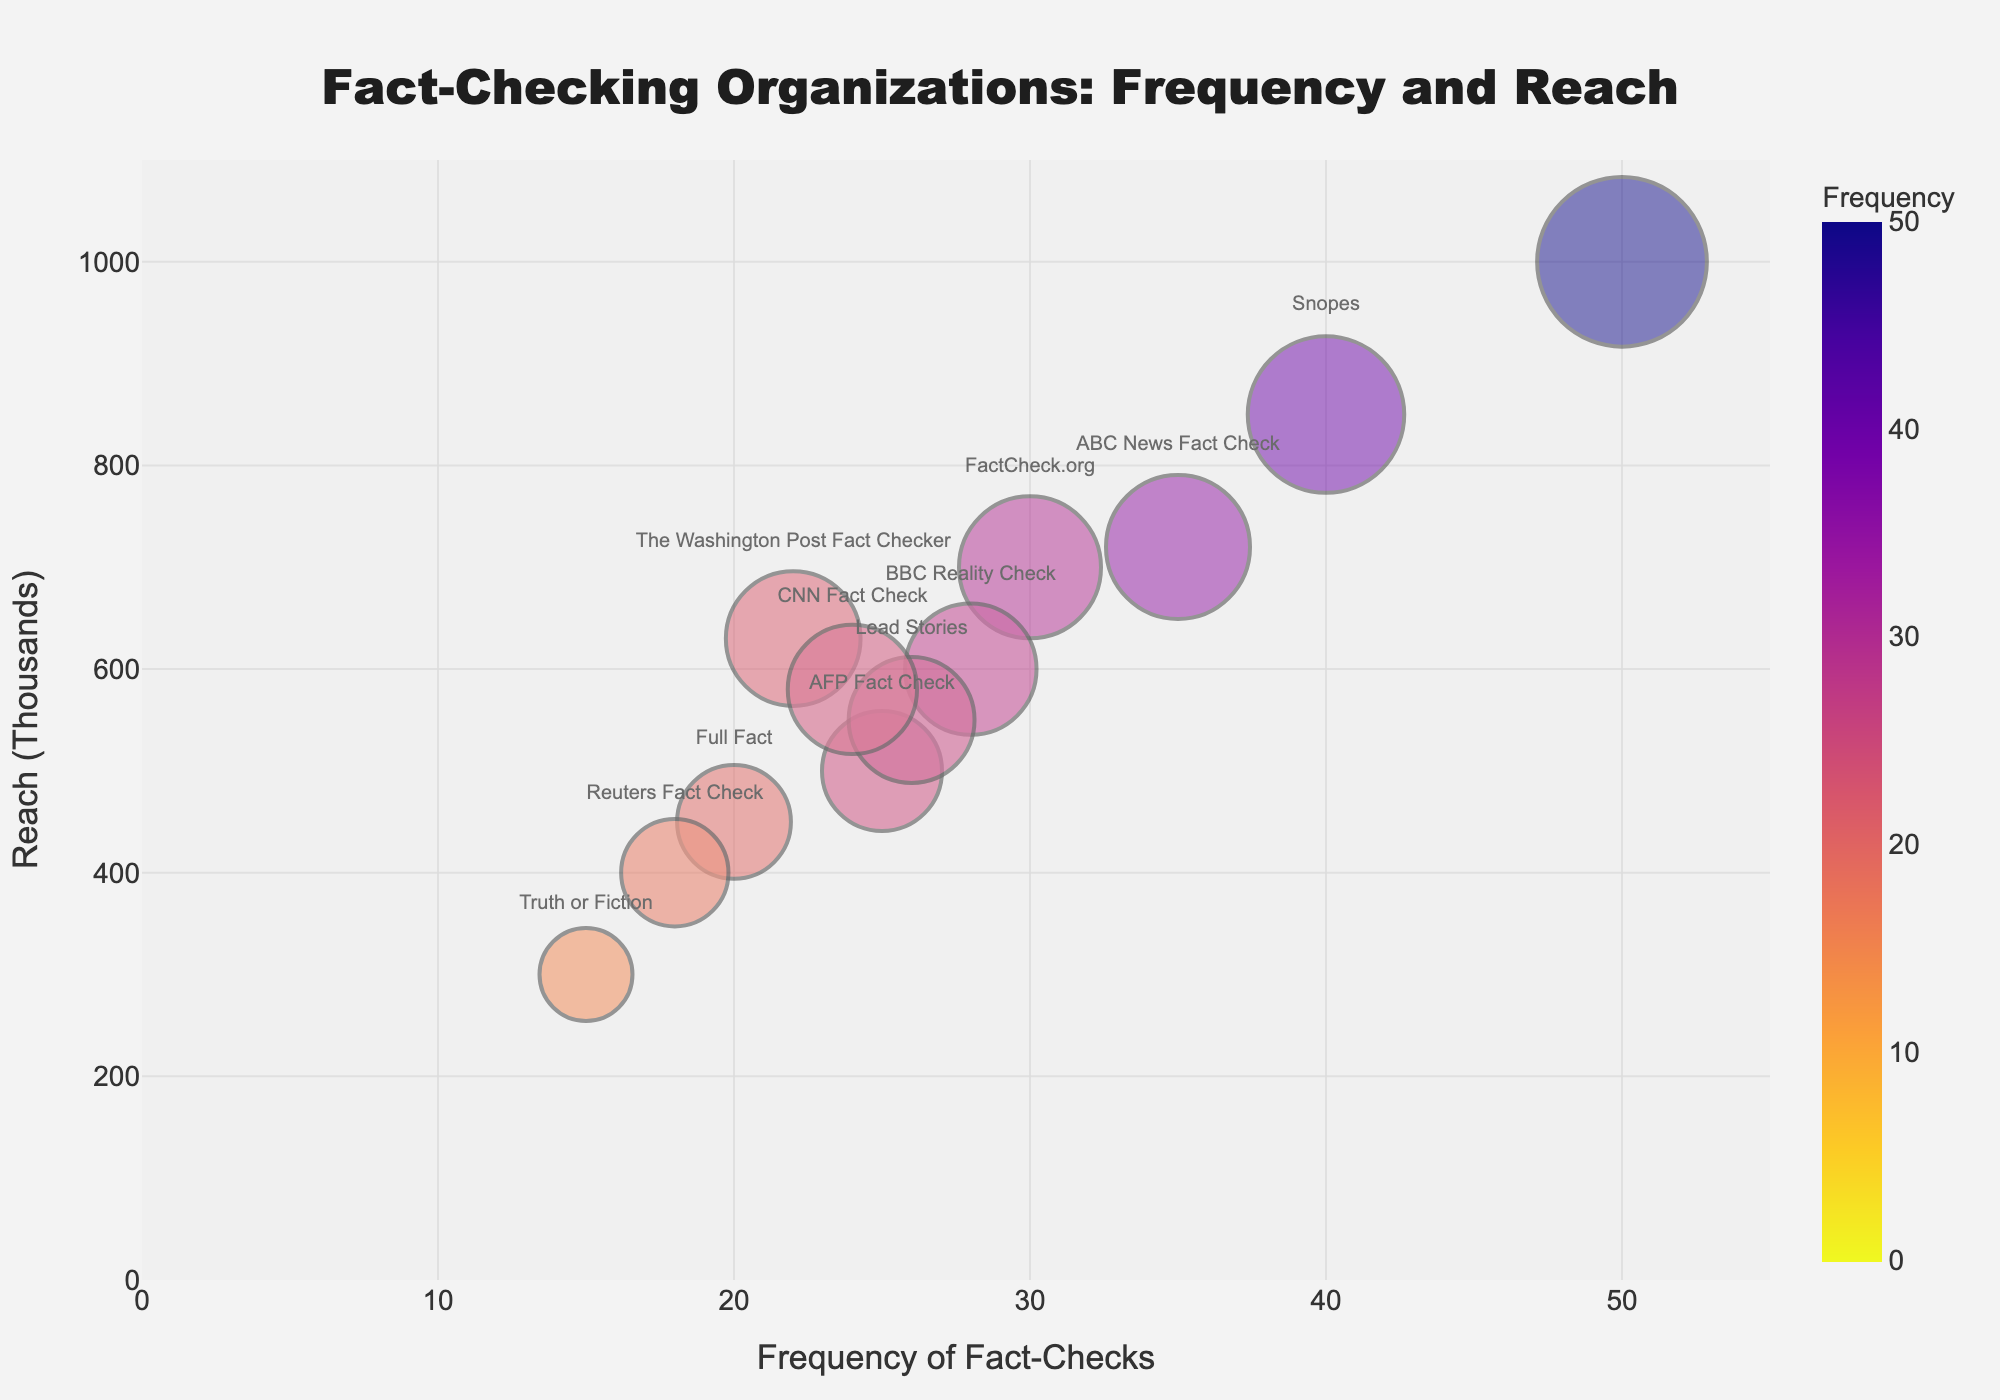What is the title of this bubble chart? At the top of the bubble chart, there is a title that provides a general overview of the visual representation. The title reads "Fact-Checking Organizations: Frequency and Reach".
Answer: Fact-Checking Organizations: Frequency and Reach Which organization has the highest frequency of fact-checks? The organization with the highest frequency will have its bubble furthest to the right. The chart shows that "PolitiFact" has the highest frequency at 50 fact-checks.
Answer: PolitiFact How many organizations are plotted on this chart? Each organization is represented by one bubble, and the number of bubbles corresponds to the number of organizations. Counting the bubbles or looking at the "Organization" column in the data, there are 12 organizations.
Answer: 12 Which organization has the largest reach? The size of the bubbles represents the reach, so the largest bubble will indicate the organization with the largest reach. PolitiFact, with a reach of 1000, has the largest bubble.
Answer: PolitiFact What is the average reach of all organizations combined? To find the average reach, sum up the reach values of all organizations and then divide by the number of organizations. (1000 + 850 + 700 + 720 + 500 + 450 + 400 + 600 + 550 + 630 + 300 + 580) / 12 = 7283 / 12 = 606.9167. Rounding to one decimal place, the average reach is 606.9.
Answer: 606.9 Which organizations fall below the average reach? First, calculate the average reach (606.9). Then, identify which organizations have a reach value less than this average. They are AFP Fact Check (500), Full Fact (450), Reuters Fact Check (400), BBC Reality Check (600), Lead Stories (550), Truth or Fiction (300), and CNN Fact Check (580).
Answer: AFP Fact Check, Full Fact, Reuters Fact Check, BBC Reality Check, Lead Stories, Truth or Fiction, CNN Fact Check What is the difference in reach between the organizations with the second-highest and second-lowest frequency of fact-checks? The second-highest frequency is Snopes with a frequency of 40 and a reach of 850. The second-lowest frequency is Truth or Fiction with a frequency of 15 and a reach of 300. The difference in reach is
Answer: 850 - 300 = 550 Which organization has a higher reach: FactCheck.org or The Washington Post Fact Checker? By checking their respective bubbles, FactCheck.org has a reach of 700, and The Washington Post Fact Checker has a reach of 630. Therefore, FactCheck.org has a higher reach.
Answer: FactCheck.org What is the relationship between frequency of fact-checks and reach for PolitiFact? Referring to PolitiFact's bubble, it has the highest frequency of fact-checks at 50 and also the largest reach of 1000. This indicates a positive correlation between high frequency and high reach for PolitiFact.
Answer: Positive correlation 